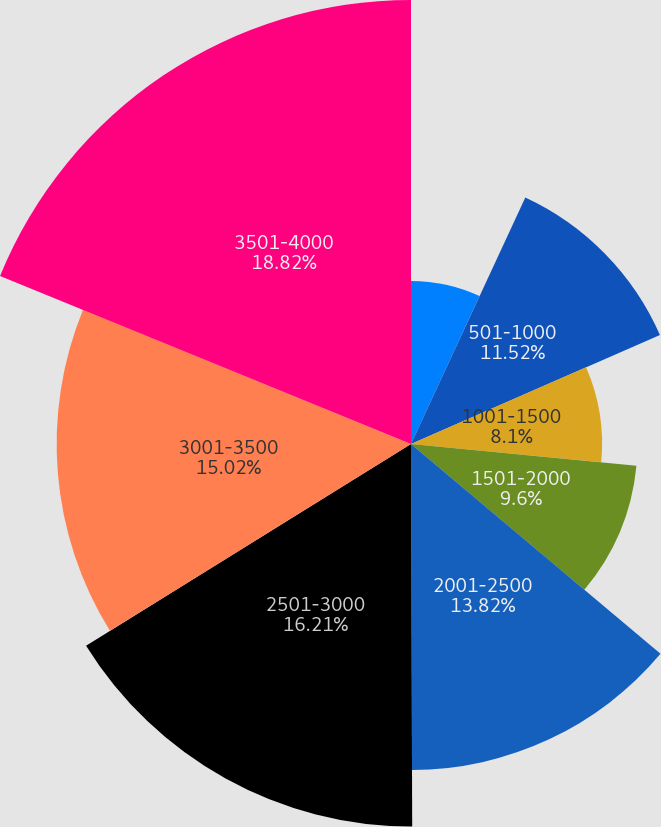<chart> <loc_0><loc_0><loc_500><loc_500><pie_chart><fcel>000- 500<fcel>501-1000<fcel>1001-1500<fcel>1501-2000<fcel>2001-2500<fcel>2501-3000<fcel>3001-3500<fcel>3501-4000<nl><fcel>6.91%<fcel>11.52%<fcel>8.1%<fcel>9.6%<fcel>13.82%<fcel>16.21%<fcel>15.02%<fcel>18.82%<nl></chart> 